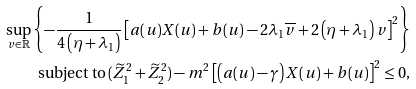<formula> <loc_0><loc_0><loc_500><loc_500>\sup _ { v \in \mathbb { R } } \left \{ - \frac { 1 } { 4 \left ( \eta + \lambda _ { 1 } \right ) } \left [ a ( u ) X ( u ) + b ( u ) - 2 \lambda _ { 1 } \overline { v } + 2 \left ( \eta + \lambda _ { 1 } \right ) v \right ] ^ { 2 } \right \} \\ \text {subject to} \, ( \widetilde { Z } _ { 1 } ^ { 2 } + \widetilde { Z } _ { 2 } ^ { 2 } ) - m ^ { 2 } \left [ \left ( a ( u ) - \gamma \right ) X ( u ) + b ( u ) \right ] ^ { 2 } \leq 0 ,</formula> 